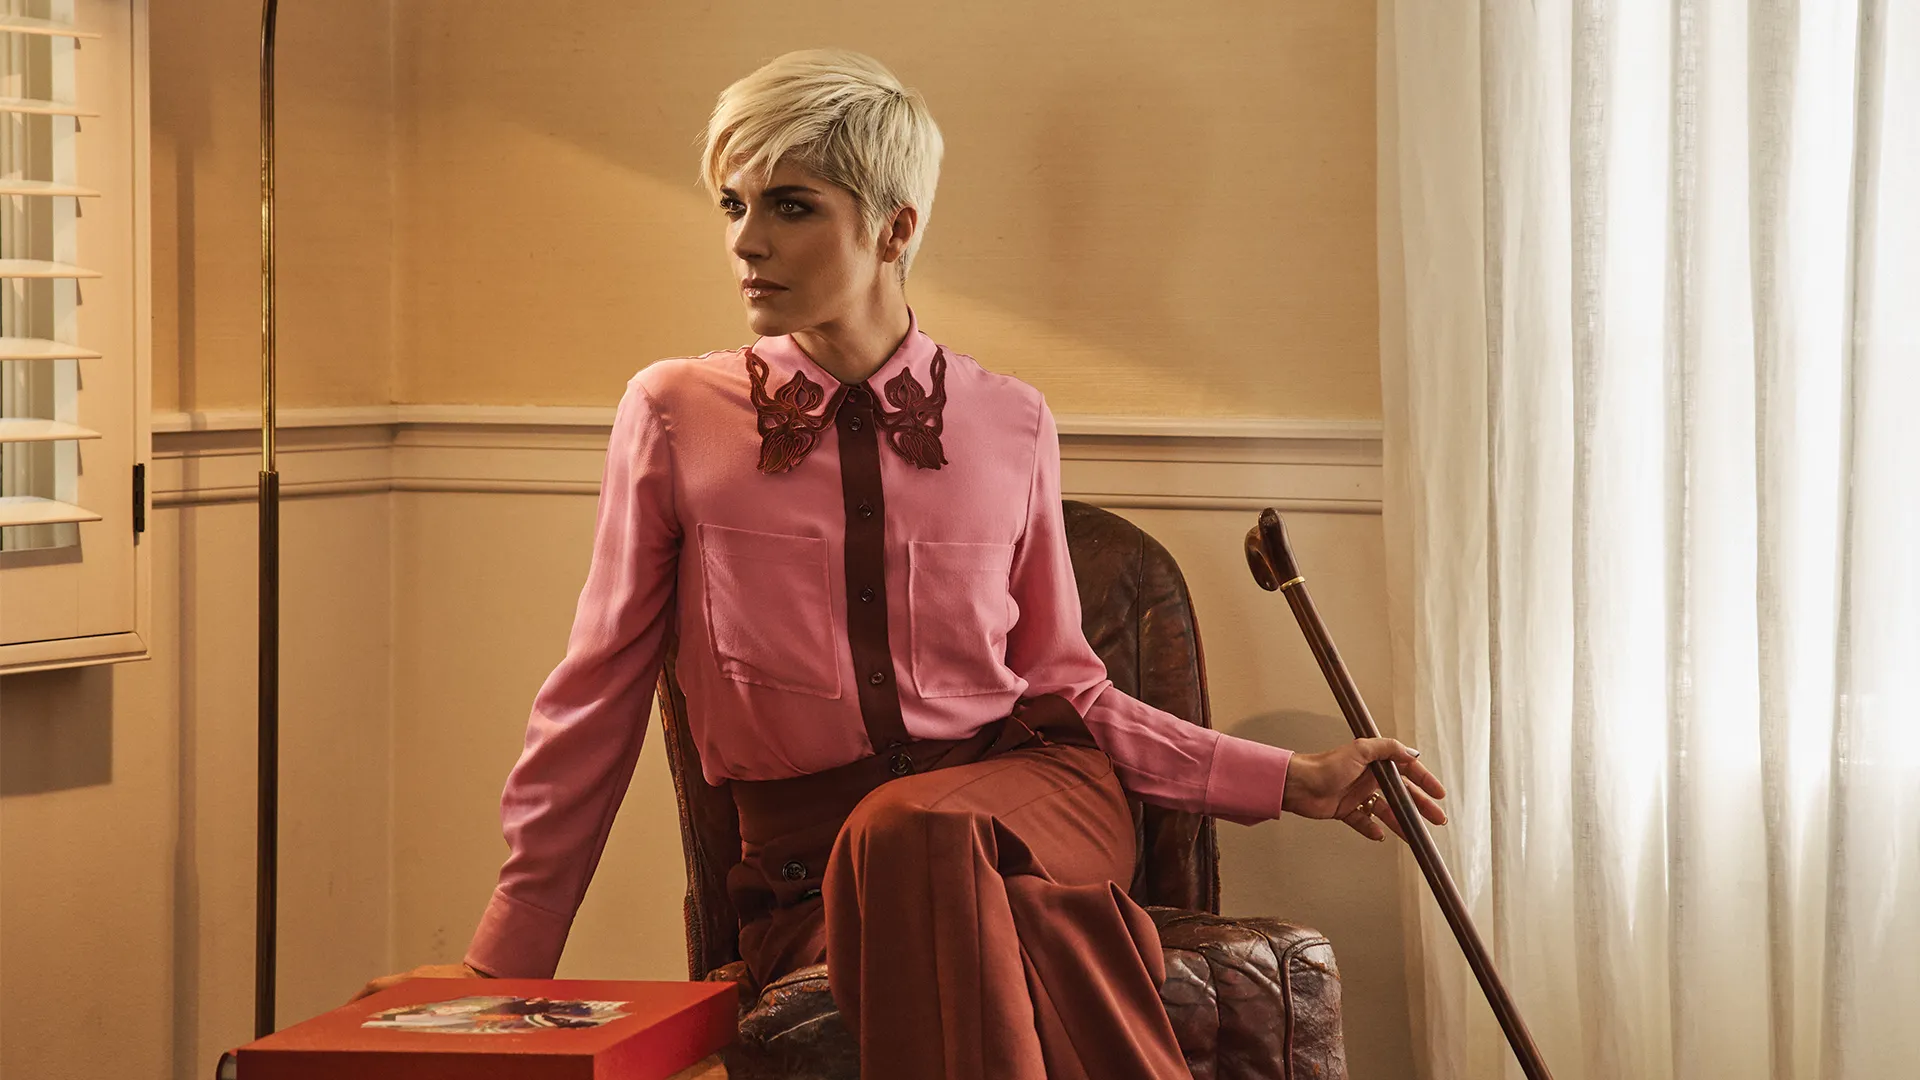What does the setting of this image convey about the woman’s character? The setting is minimal and understated, with a beige wall and white curtains that do not distract from the woman herself. This environment conveys a sense of simplicity and focus, suggesting that the woman values inner strength and personal resilience over materialism. The brown leather armchair adds a touch of sophistication and comfort, implying a life of dignity and contemplation. The presence of the cane highlights her determination to cope with physical challenges gracefully. 